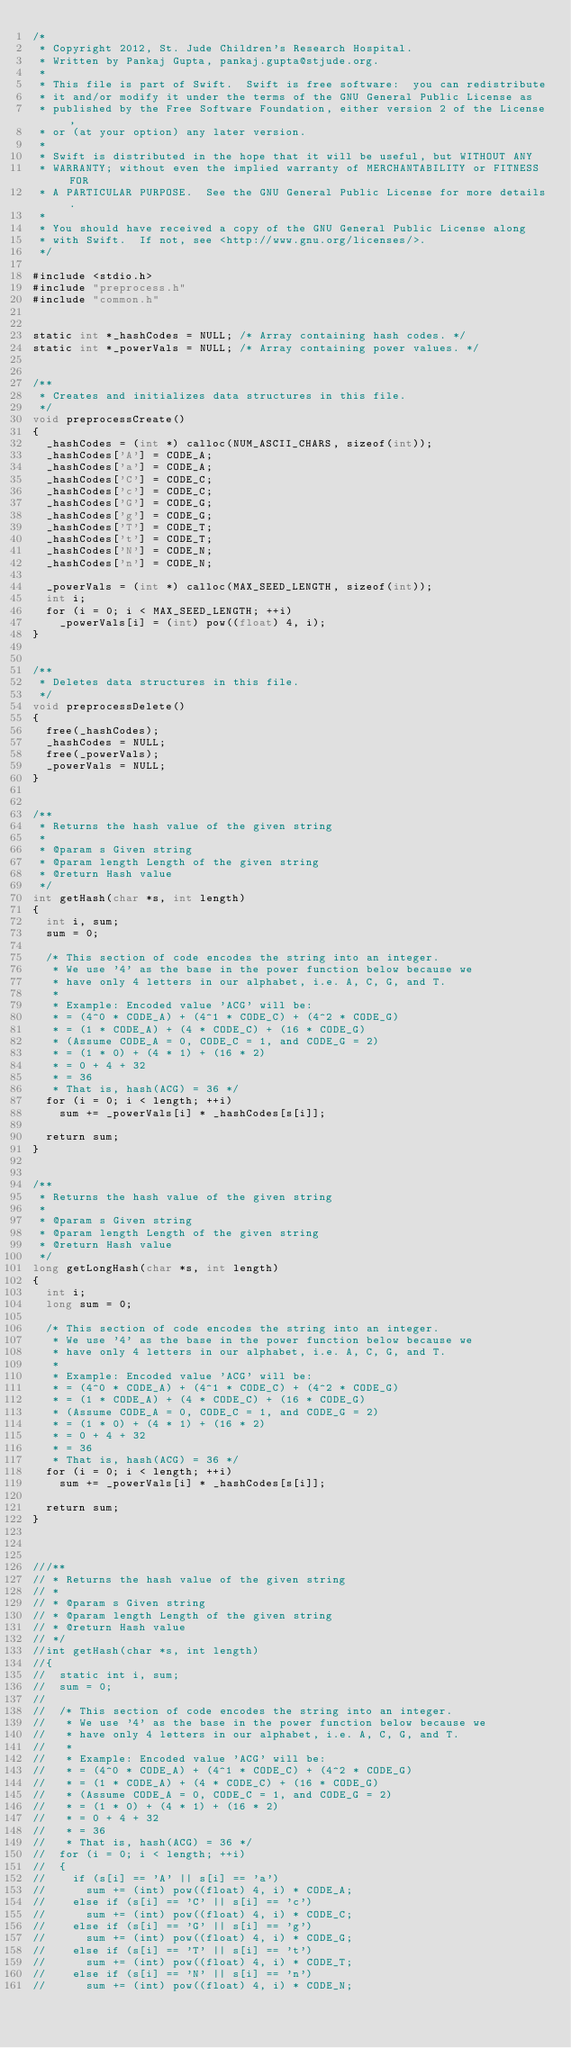Convert code to text. <code><loc_0><loc_0><loc_500><loc_500><_Cuda_>/*
 * Copyright 2012, St. Jude Children's Research Hospital.
 * Written by Pankaj Gupta, pankaj.gupta@stjude.org.
 *
 * This file is part of Swift.  Swift is free software:  you can redistribute
 * it and/or modify it under the terms of the GNU General Public License as
 * published by the Free Software Foundation, either version 2 of the License,
 * or (at your option) any later version.
 *
 * Swift is distributed in the hope that it will be useful, but WITHOUT ANY
 * WARRANTY; without even the implied warranty of MERCHANTABILITY or FITNESS FOR
 * A PARTICULAR PURPOSE.  See the GNU General Public License for more details.
 *
 * You should have received a copy of the GNU General Public License along
 * with Swift.  If not, see <http://www.gnu.org/licenses/>.
 */

#include <stdio.h>
#include "preprocess.h"
#include "common.h"


static int *_hashCodes = NULL; /* Array containing hash codes. */
static int *_powerVals = NULL; /* Array containing power values. */


/**
 * Creates and initializes data structures in this file.
 */
void preprocessCreate()
{
	_hashCodes = (int *) calloc(NUM_ASCII_CHARS, sizeof(int));
	_hashCodes['A'] = CODE_A;
	_hashCodes['a'] = CODE_A;
	_hashCodes['C'] = CODE_C;
	_hashCodes['c'] = CODE_C;
	_hashCodes['G'] = CODE_G;
	_hashCodes['g'] = CODE_G;
	_hashCodes['T'] = CODE_T;
	_hashCodes['t'] = CODE_T;
	_hashCodes['N'] = CODE_N;
	_hashCodes['n'] = CODE_N;

	_powerVals = (int *) calloc(MAX_SEED_LENGTH, sizeof(int));
	int i;
	for (i = 0; i < MAX_SEED_LENGTH; ++i)
		_powerVals[i] = (int) pow((float) 4, i);
}


/**
 * Deletes data structures in this file.
 */
void preprocessDelete()
{
	free(_hashCodes);
	_hashCodes = NULL;
	free(_powerVals);
	_powerVals = NULL;
}


/**
 * Returns the hash value of the given string
 *
 * @param s Given string
 * @param length Length of the given string
 * @return Hash value
 */
int getHash(char *s, int length)
{
	int i, sum;
	sum = 0;

	/* This section of code encodes the string into an integer.
	 * We use '4' as the base in the power function below because we
	 * have only 4 letters in our alphabet, i.e. A, C, G, and T.
	 *
	 * Example: Encoded value 'ACG' will be:
	 * = (4^0 * CODE_A) + (4^1 * CODE_C) + (4^2 * CODE_G)
	 * = (1 * CODE_A) + (4 * CODE_C) + (16 * CODE_G)
	 * (Assume CODE_A = 0, CODE_C = 1, and CODE_G = 2)
	 * = (1 * 0) + (4 * 1) + (16 * 2)
	 * = 0 + 4 + 32
	 * = 36
	 * That is, hash(ACG) = 36 */
	for (i = 0; i < length; ++i)
		sum += _powerVals[i] * _hashCodes[s[i]];

	return sum;
}


/**
 * Returns the hash value of the given string
 *
 * @param s Given string
 * @param length Length of the given string
 * @return Hash value
 */
long getLongHash(char *s, int length)
{
	int i;
	long sum = 0;

	/* This section of code encodes the string into an integer.
	 * We use '4' as the base in the power function below because we
	 * have only 4 letters in our alphabet, i.e. A, C, G, and T.
	 *
	 * Example: Encoded value 'ACG' will be:
	 * = (4^0 * CODE_A) + (4^1 * CODE_C) + (4^2 * CODE_G)
	 * = (1 * CODE_A) + (4 * CODE_C) + (16 * CODE_G)
	 * (Assume CODE_A = 0, CODE_C = 1, and CODE_G = 2)
	 * = (1 * 0) + (4 * 1) + (16 * 2)
	 * = 0 + 4 + 32
	 * = 36
	 * That is, hash(ACG) = 36 */
	for (i = 0; i < length; ++i)
		sum += _powerVals[i] * _hashCodes[s[i]];

	return sum;
}



///**
// * Returns the hash value of the given string
// *
// * @param s Given string
// * @param length Length of the given string
// * @return Hash value
// */
//int getHash(char *s, int length)
//{
//	static int i, sum;
//	sum = 0;
//
//	/* This section of code encodes the string into an integer.
//	 * We use '4' as the base in the power function below because we
//	 * have only 4 letters in our alphabet, i.e. A, C, G, and T.
//	 *
//	 * Example: Encoded value 'ACG' will be:
//	 * = (4^0 * CODE_A) + (4^1 * CODE_C) + (4^2 * CODE_G)
//	 * = (1 * CODE_A) + (4 * CODE_C) + (16 * CODE_G)
//	 * (Assume CODE_A = 0, CODE_C = 1, and CODE_G = 2)
//	 * = (1 * 0) + (4 * 1) + (16 * 2)
//	 * = 0 + 4 + 32
//	 * = 36
//	 * That is, hash(ACG) = 36 */
//	for (i = 0; i < length; ++i)
//	{
//		if (s[i] == 'A' || s[i] == 'a')
//			sum += (int) pow((float) 4, i) * CODE_A;
//		else if (s[i] == 'C' || s[i] == 'c')
//			sum += (int) pow((float) 4, i) * CODE_C;
//		else if (s[i] == 'G' || s[i] == 'g')
//			sum += (int) pow((float) 4, i) * CODE_G;
//		else if (s[i] == 'T' || s[i] == 't')
//			sum += (int) pow((float) 4, i) * CODE_T;
//		else if (s[i] == 'N' || s[i] == 'n')
//			sum += (int) pow((float) 4, i) * CODE_N;</code> 